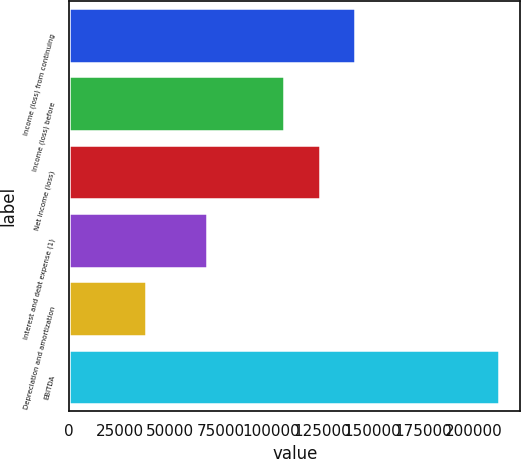Convert chart to OTSL. <chart><loc_0><loc_0><loc_500><loc_500><bar_chart><fcel>Income (loss) from continuing<fcel>Income (loss) before<fcel>Net income (loss)<fcel>Interest and debt expense (1)<fcel>Depreciation and amortization<fcel>EBITDA<nl><fcel>141421<fcel>106472<fcel>123947<fcel>68274<fcel>37954<fcel>212700<nl></chart> 